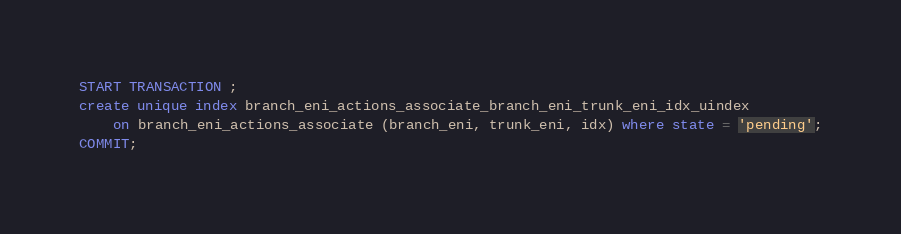<code> <loc_0><loc_0><loc_500><loc_500><_SQL_>START TRANSACTION ;
create unique index branch_eni_actions_associate_branch_eni_trunk_eni_idx_uindex
    on branch_eni_actions_associate (branch_eni, trunk_eni, idx) where state = 'pending';
COMMIT;
</code> 